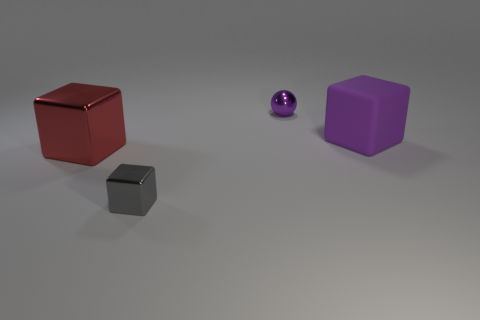Subtract all large blocks. How many blocks are left? 1 Subtract 1 blocks. How many blocks are left? 2 Add 3 large purple objects. How many objects exist? 7 Subtract all balls. How many objects are left? 3 Subtract all small red rubber cylinders. Subtract all small gray shiny objects. How many objects are left? 3 Add 3 small gray shiny things. How many small gray shiny things are left? 4 Add 1 large cyan matte cylinders. How many large cyan matte cylinders exist? 1 Subtract 0 green cylinders. How many objects are left? 4 